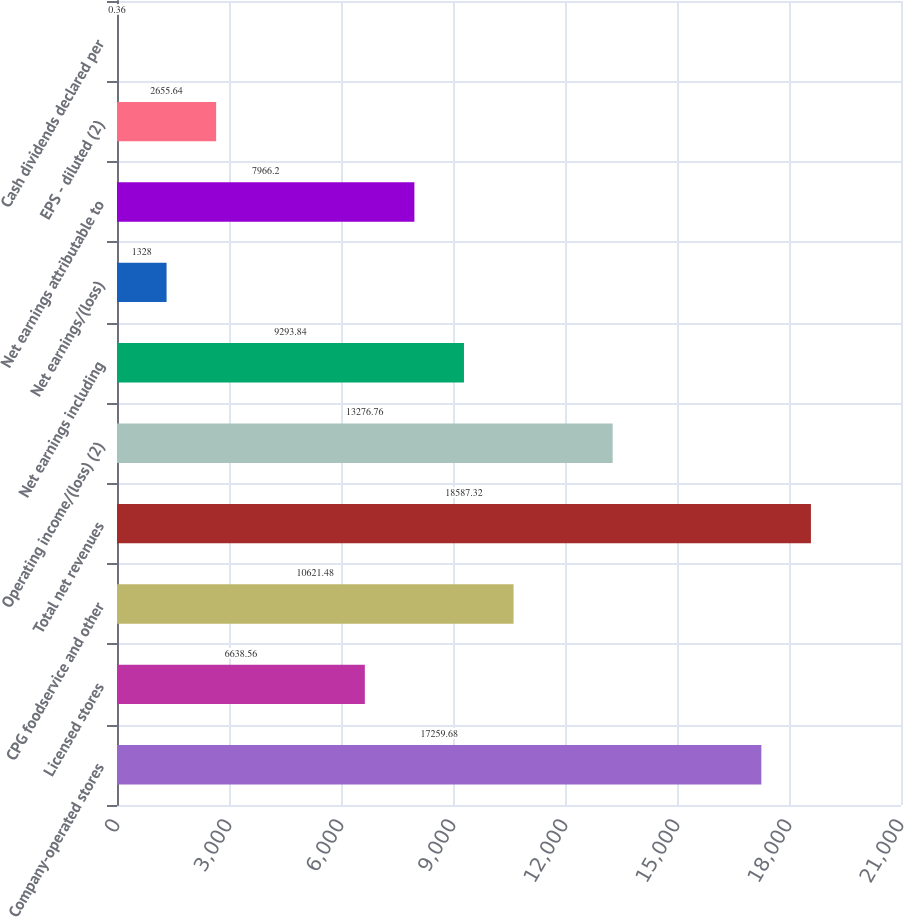<chart> <loc_0><loc_0><loc_500><loc_500><bar_chart><fcel>Company-operated stores<fcel>Licensed stores<fcel>CPG foodservice and other<fcel>Total net revenues<fcel>Operating income/(loss) (2)<fcel>Net earnings including<fcel>Net earnings/(loss)<fcel>Net earnings attributable to<fcel>EPS - diluted (2)<fcel>Cash dividends declared per<nl><fcel>17259.7<fcel>6638.56<fcel>10621.5<fcel>18587.3<fcel>13276.8<fcel>9293.84<fcel>1328<fcel>7966.2<fcel>2655.64<fcel>0.36<nl></chart> 